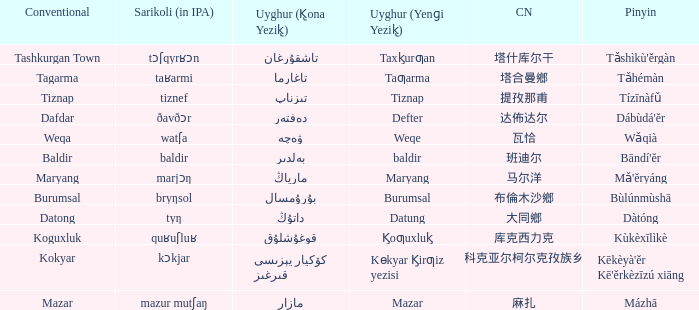Could you parse the entire table as a dict? {'header': ['Conventional', 'Sarikoli (in IPA)', 'Uyghur (K̢ona Yezik̢)', 'Uyghur (Yenɡi Yezik̢)', 'CN', 'Pinyin'], 'rows': [['Tashkurgan Town', 'tɔʃqyrʁɔn', 'تاشقۇرغان', 'Taxk̡urƣan', '塔什库尔干', "Tǎshìkù'ěrgàn"], ['Tagarma', 'taʁarmi', 'تاغارما', 'Taƣarma', '塔合曼鄉', 'Tǎhémàn'], ['Tiznap', 'tiznef', 'تىزناپ', 'Tiznap', '提孜那甫', 'Tízīnàfǔ'], ['Dafdar', 'ðavðɔr', 'دەفتەر', 'Defter', '达佈达尔', "Dábùdá'ĕr"], ['Weqa', 'watʃa', 'ۋەچە', 'Weqe', '瓦恰', 'Wǎqià'], ['Baldir', 'baldir', 'بەلدىر', 'baldir', '班迪尔', "Bāndí'ĕr"], ['Maryang', 'marjɔŋ', 'مارياڭ', 'Maryang', '马尔洋', "Mǎ'ĕryáng"], ['Burumsal', 'bryŋsol', 'بۇرۇمسال', 'Burumsal', '布倫木沙鄉', 'Bùlúnmùshā'], ['Datong', 'tyŋ', 'داتۇڭ', 'Datung', '大同鄉', 'Dàtóng'], ['Koguxluk', 'quʁuʃluʁ', 'قوغۇشلۇق', 'K̡oƣuxluk̡', '库克西力克', 'Kùkèxīlìkè'], ['Kokyar', 'kɔkjar', 'كۆكيار قىرغىز يېزىسى', 'Kɵkyar K̡irƣiz yezisi', '科克亚尔柯尔克孜族乡', "Kēkèyà'ěr Kē'ěrkèzīzú xiāng"], ['Mazar', 'mazur mutʃaŋ', 'مازار', 'Mazar', '麻扎', 'Mázhā']]} Name the pinyin for تىزناپ Tízīnàfǔ. 